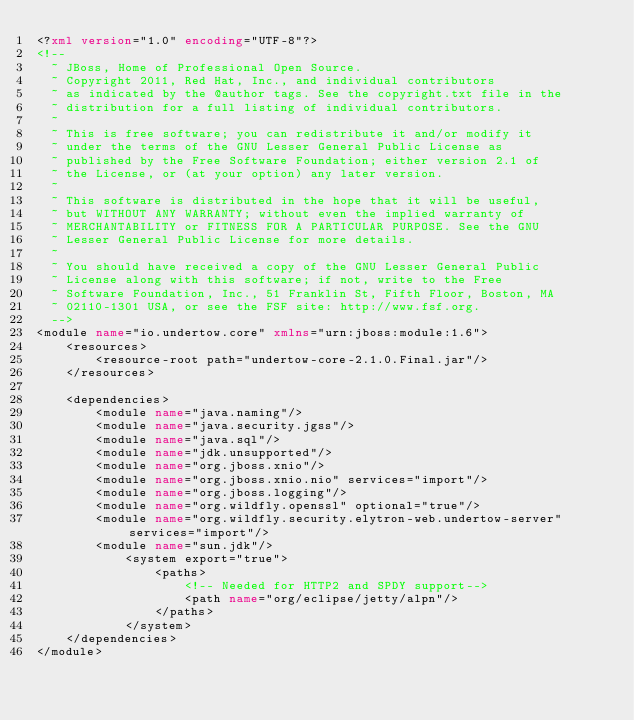<code> <loc_0><loc_0><loc_500><loc_500><_XML_><?xml version="1.0" encoding="UTF-8"?>
<!--
  ~ JBoss, Home of Professional Open Source.
  ~ Copyright 2011, Red Hat, Inc., and individual contributors
  ~ as indicated by the @author tags. See the copyright.txt file in the
  ~ distribution for a full listing of individual contributors.
  ~
  ~ This is free software; you can redistribute it and/or modify it
  ~ under the terms of the GNU Lesser General Public License as
  ~ published by the Free Software Foundation; either version 2.1 of
  ~ the License, or (at your option) any later version.
  ~
  ~ This software is distributed in the hope that it will be useful,
  ~ but WITHOUT ANY WARRANTY; without even the implied warranty of
  ~ MERCHANTABILITY or FITNESS FOR A PARTICULAR PURPOSE. See the GNU
  ~ Lesser General Public License for more details.
  ~
  ~ You should have received a copy of the GNU Lesser General Public
  ~ License along with this software; if not, write to the Free
  ~ Software Foundation, Inc., 51 Franklin St, Fifth Floor, Boston, MA
  ~ 02110-1301 USA, or see the FSF site: http://www.fsf.org.
  -->
<module name="io.undertow.core" xmlns="urn:jboss:module:1.6">
    <resources>
        <resource-root path="undertow-core-2.1.0.Final.jar"/>
    </resources>

    <dependencies>
        <module name="java.naming"/>
        <module name="java.security.jgss"/>
        <module name="java.sql"/>
        <module name="jdk.unsupported"/>
        <module name="org.jboss.xnio"/>
        <module name="org.jboss.xnio.nio" services="import"/>
        <module name="org.jboss.logging"/>
        <module name="org.wildfly.openssl" optional="true"/>
        <module name="org.wildfly.security.elytron-web.undertow-server" services="import"/>
        <module name="sun.jdk"/>
            <system export="true">
                <paths>
                    <!-- Needed for HTTP2 and SPDY support-->
                    <path name="org/eclipse/jetty/alpn"/>
                </paths>
            </system>
    </dependencies>
</module>
</code> 